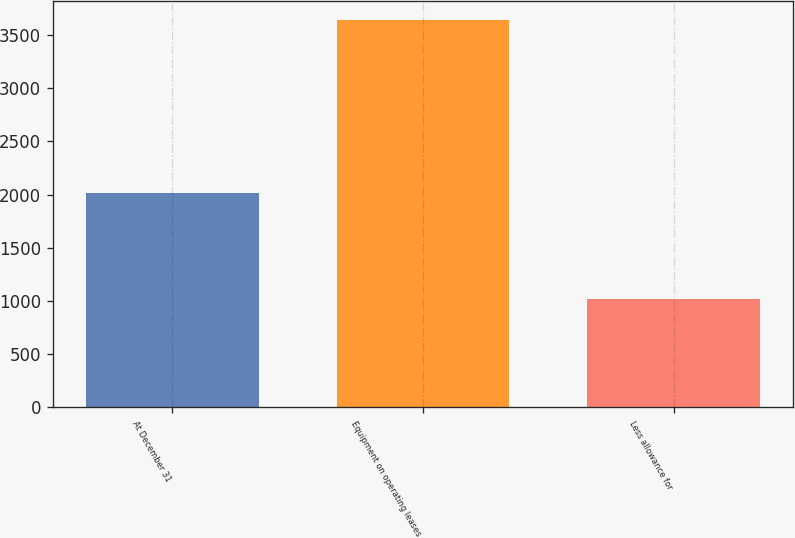Convert chart to OTSL. <chart><loc_0><loc_0><loc_500><loc_500><bar_chart><fcel>At December 31<fcel>Equipment on operating leases<fcel>Less allowance for<nl><fcel>2016<fcel>3640.6<fcel>1016.7<nl></chart> 